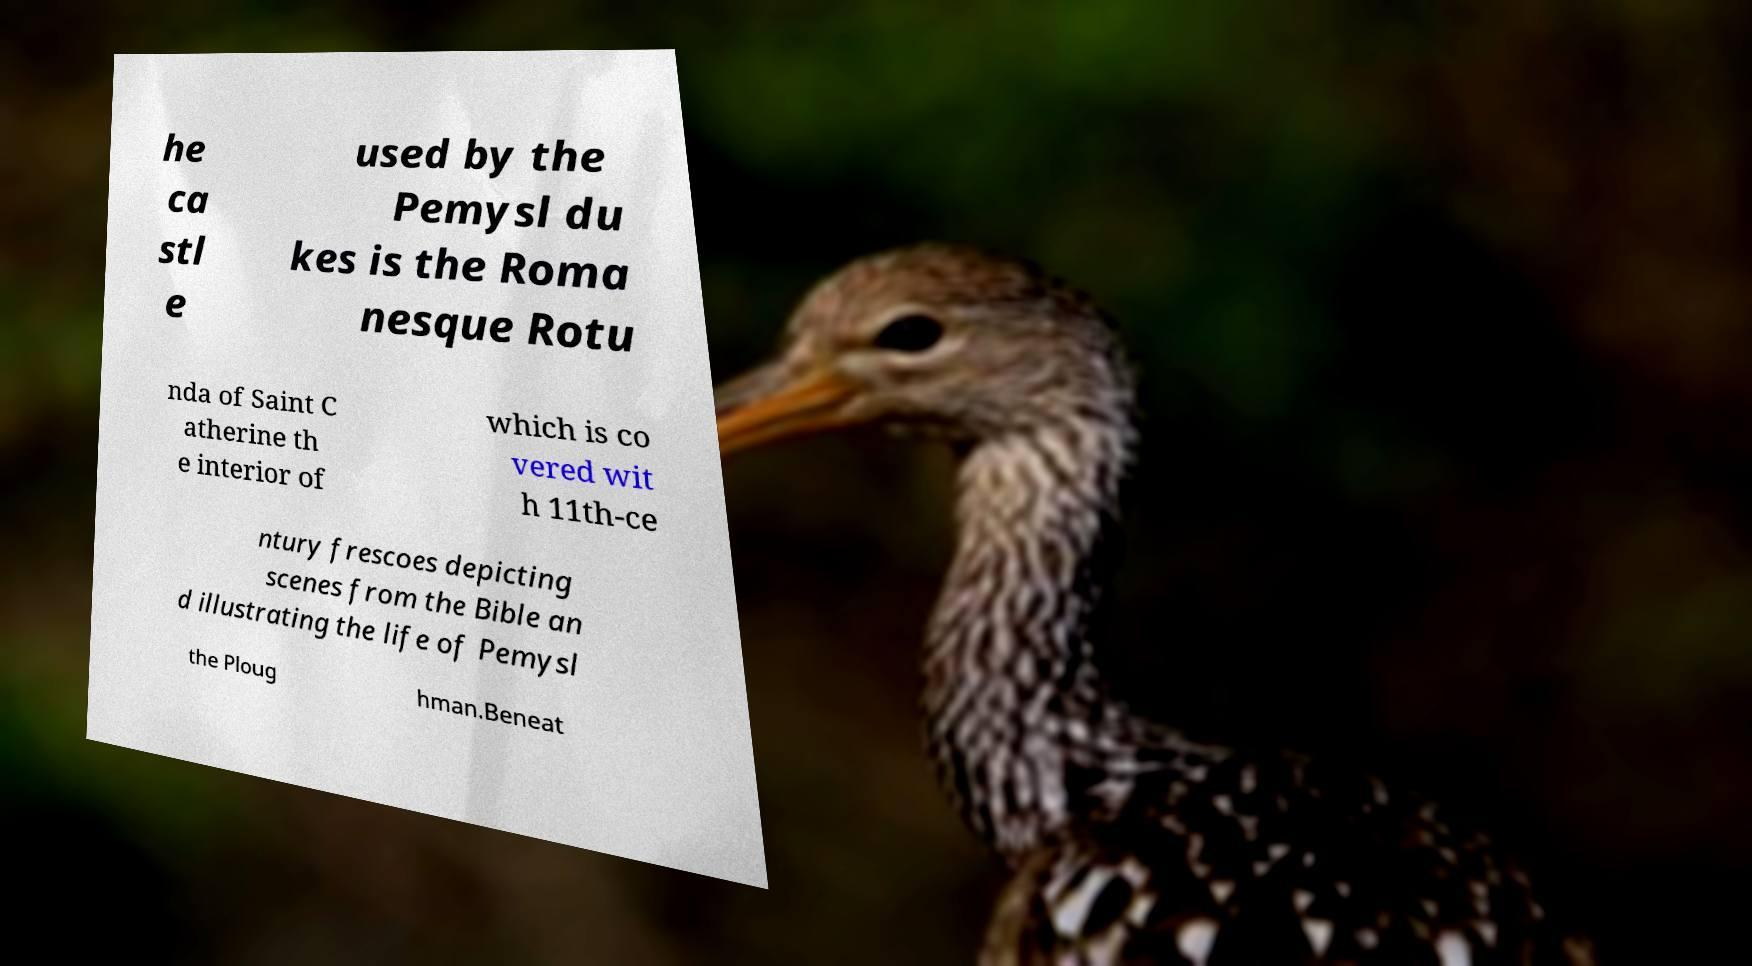I need the written content from this picture converted into text. Can you do that? he ca stl e used by the Pemysl du kes is the Roma nesque Rotu nda of Saint C atherine th e interior of which is co vered wit h 11th-ce ntury frescoes depicting scenes from the Bible an d illustrating the life of Pemysl the Ploug hman.Beneat 